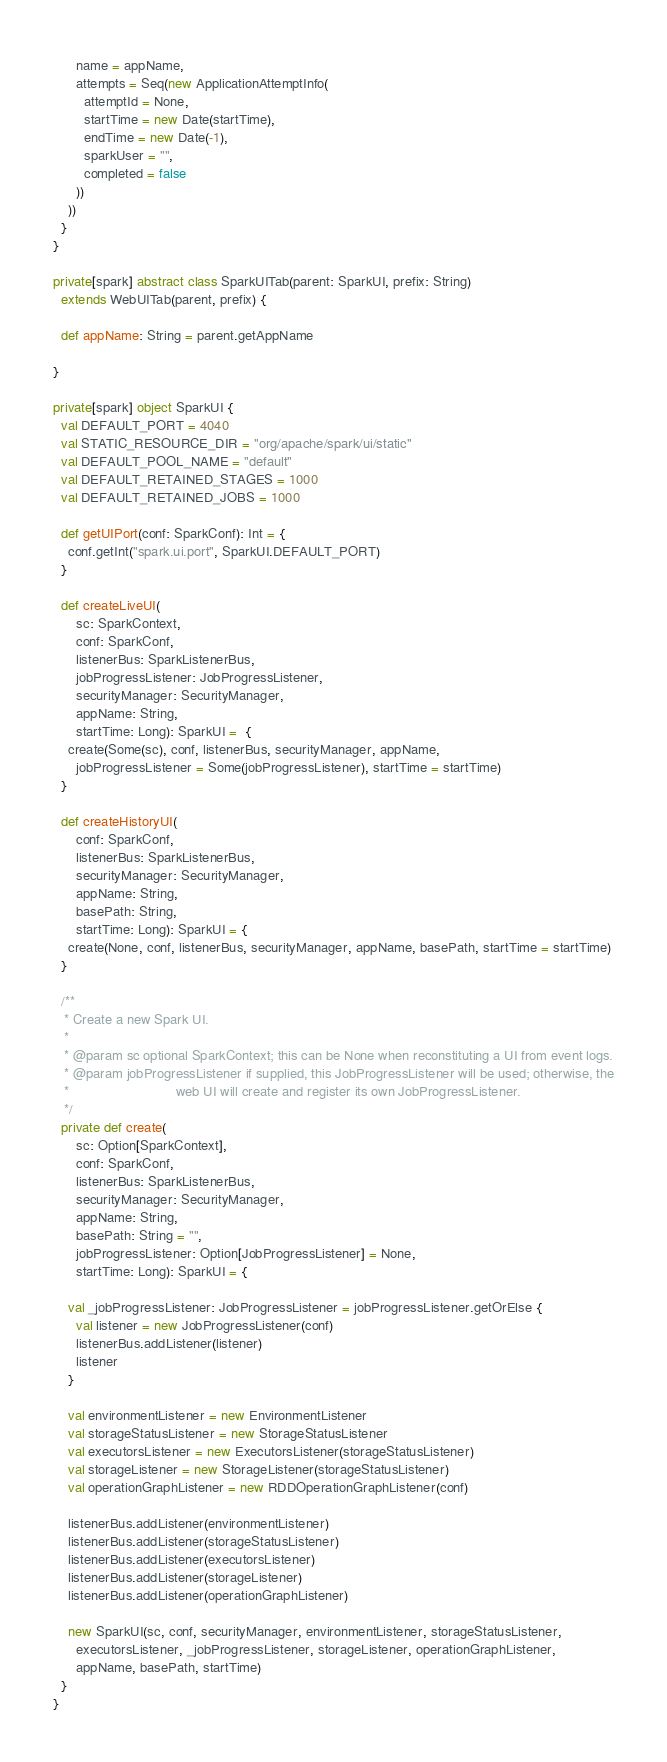<code> <loc_0><loc_0><loc_500><loc_500><_Scala_>      name = appName,
      attempts = Seq(new ApplicationAttemptInfo(
        attemptId = None,
        startTime = new Date(startTime),
        endTime = new Date(-1),
        sparkUser = "",
        completed = false
      ))
    ))
  }
}

private[spark] abstract class SparkUITab(parent: SparkUI, prefix: String)
  extends WebUITab(parent, prefix) {

  def appName: String = parent.getAppName

}

private[spark] object SparkUI {
  val DEFAULT_PORT = 4040
  val STATIC_RESOURCE_DIR = "org/apache/spark/ui/static"
  val DEFAULT_POOL_NAME = "default"
  val DEFAULT_RETAINED_STAGES = 1000
  val DEFAULT_RETAINED_JOBS = 1000

  def getUIPort(conf: SparkConf): Int = {
    conf.getInt("spark.ui.port", SparkUI.DEFAULT_PORT)
  }

  def createLiveUI(
      sc: SparkContext,
      conf: SparkConf,
      listenerBus: SparkListenerBus,
      jobProgressListener: JobProgressListener,
      securityManager: SecurityManager,
      appName: String,
      startTime: Long): SparkUI =  {
    create(Some(sc), conf, listenerBus, securityManager, appName,
      jobProgressListener = Some(jobProgressListener), startTime = startTime)
  }

  def createHistoryUI(
      conf: SparkConf,
      listenerBus: SparkListenerBus,
      securityManager: SecurityManager,
      appName: String,
      basePath: String,
      startTime: Long): SparkUI = {
    create(None, conf, listenerBus, securityManager, appName, basePath, startTime = startTime)
  }

  /**
   * Create a new Spark UI.
   *
   * @param sc optional SparkContext; this can be None when reconstituting a UI from event logs.
   * @param jobProgressListener if supplied, this JobProgressListener will be used; otherwise, the
   *                            web UI will create and register its own JobProgressListener.
   */
  private def create(
      sc: Option[SparkContext],
      conf: SparkConf,
      listenerBus: SparkListenerBus,
      securityManager: SecurityManager,
      appName: String,
      basePath: String = "",
      jobProgressListener: Option[JobProgressListener] = None,
      startTime: Long): SparkUI = {

    val _jobProgressListener: JobProgressListener = jobProgressListener.getOrElse {
      val listener = new JobProgressListener(conf)
      listenerBus.addListener(listener)
      listener
    }

    val environmentListener = new EnvironmentListener
    val storageStatusListener = new StorageStatusListener
    val executorsListener = new ExecutorsListener(storageStatusListener)
    val storageListener = new StorageListener(storageStatusListener)
    val operationGraphListener = new RDDOperationGraphListener(conf)

    listenerBus.addListener(environmentListener)
    listenerBus.addListener(storageStatusListener)
    listenerBus.addListener(executorsListener)
    listenerBus.addListener(storageListener)
    listenerBus.addListener(operationGraphListener)

    new SparkUI(sc, conf, securityManager, environmentListener, storageStatusListener,
      executorsListener, _jobProgressListener, storageListener, operationGraphListener,
      appName, basePath, startTime)
  }
}
</code> 